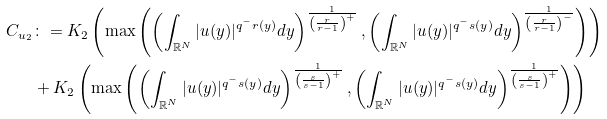Convert formula to latex. <formula><loc_0><loc_0><loc_500><loc_500>C _ { u _ { 2 } } & \colon = K _ { 2 } \left ( \max \left ( \left ( \int _ { \mathbb { R } ^ { N } } | u ( y ) | ^ { q ^ { - } r ( y ) } d y \right ) ^ { \frac { 1 } { \left ( \frac { r } { r - 1 } \right ) ^ { + } } } , \left ( \int _ { \mathbb { R } ^ { N } } | u ( y ) | ^ { q ^ { - } s ( y ) } d y \right ) ^ { \frac { 1 } { \left ( \frac { r } { r - 1 } \right ) ^ { - } } } \right ) \right ) \\ & + K _ { 2 } \left ( \max \left ( \left ( \int _ { \mathbb { R } ^ { N } } | u ( y ) | ^ { q ^ { - } s ( y ) } d y \right ) ^ { \frac { 1 } { \left ( \frac { s } { s - 1 } \right ) ^ { + } } } , \left ( \int _ { \mathbb { R } ^ { N } } | u ( y ) | ^ { q ^ { - } s ( y ) } d y \right ) ^ { \frac { 1 } { \left ( \frac { s } { s - 1 } \right ) ^ { + } } } \right ) \right )</formula> 